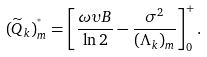Convert formula to latex. <formula><loc_0><loc_0><loc_500><loc_500>( \widetilde { Q } _ { k } ) _ { m } ^ { ^ { * } } = \left [ \frac { \omega \upsilon B } { \ln 2 } - \frac { \sigma ^ { 2 } } { ( \Lambda _ { k } ) _ { m } } \right ] _ { 0 } ^ { + } .</formula> 